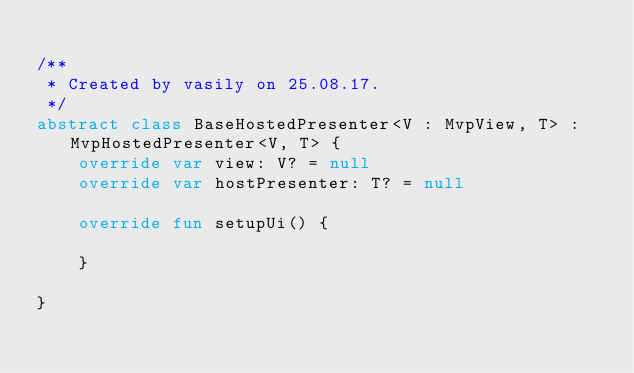<code> <loc_0><loc_0><loc_500><loc_500><_Kotlin_>
/**
 * Created by vasily on 25.08.17.
 */
abstract class BaseHostedPresenter<V : MvpView, T> : MvpHostedPresenter<V, T> {
    override var view: V? = null
    override var hostPresenter: T? = null

    override fun setupUi() {

    }

}</code> 